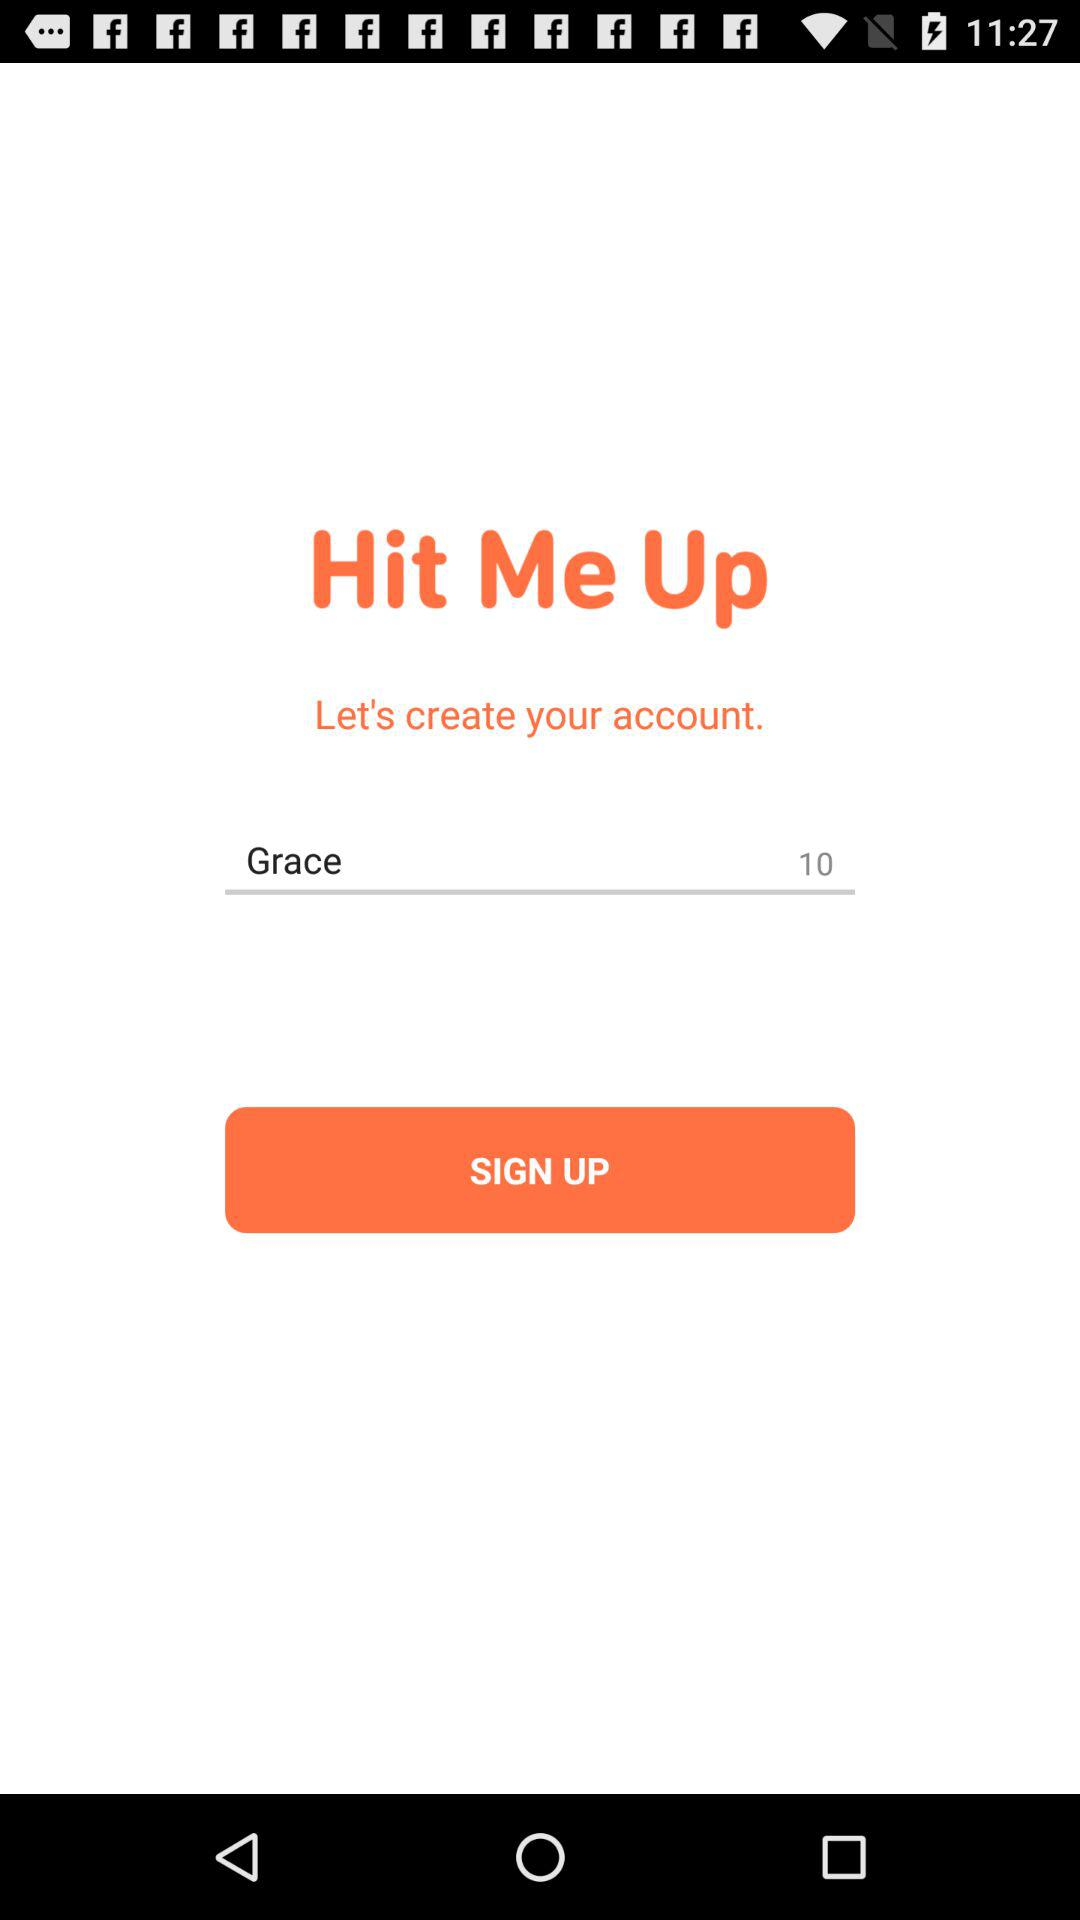What is the application name? The application name is "Hit Me Up". 